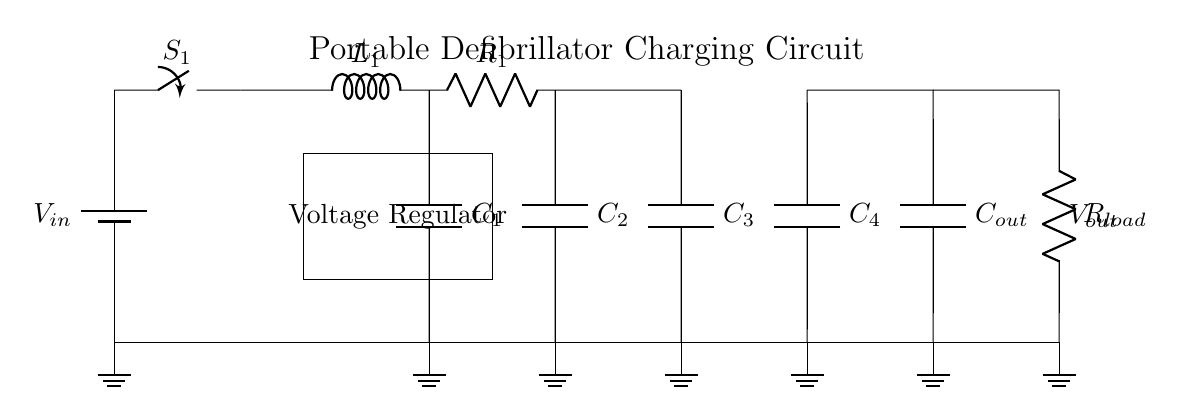What is the total number of capacitors in the circuit? The circuit diagram shows four capacitors labeled C1, C2, C3, and C4. Since there are no additional capacitors indicated, the total is four.
Answer: four What component regulates the voltage in the circuit? The circuit diagram includes a labeled section marked "Voltage Regulator." This indicates the component whose role is to maintain a constant output voltage.
Answer: Voltage Regulator What is the purpose of the switch labeled S1? The switch S1 controls the flow of current from the battery to the rest of the circuit. When closed, it allows current to pass, while when open, it stops the current flow.
Answer: Current control How many resistors are present in the circuit? Looking at the circuit, there is one resistor labeled R1. No other resistors are present, thus the answer is one.
Answer: one Describe the connection type between capacitors C3 and C4. Capacitors C3 and C4 are positioned in parallel because both are connected to the same voltage points; their positive and negative terminals are connected together, allowing them to share voltage.
Answer: parallel If all capacitors have the same capacitance value, what happens to the total capacitance when connected in parallel? In a parallel connection, capacitance values add together. Therefore, if all capacitors have the same capacitance value, the total capacitance will be the sum of all their individual values.
Answer: sum of capacitances What is the output labeled in the circuit? The output labeled in the circuit is denoted as Vout, which indicates the voltage that the circuit provides to the load after the regulation and filtering process.
Answer: Vout 